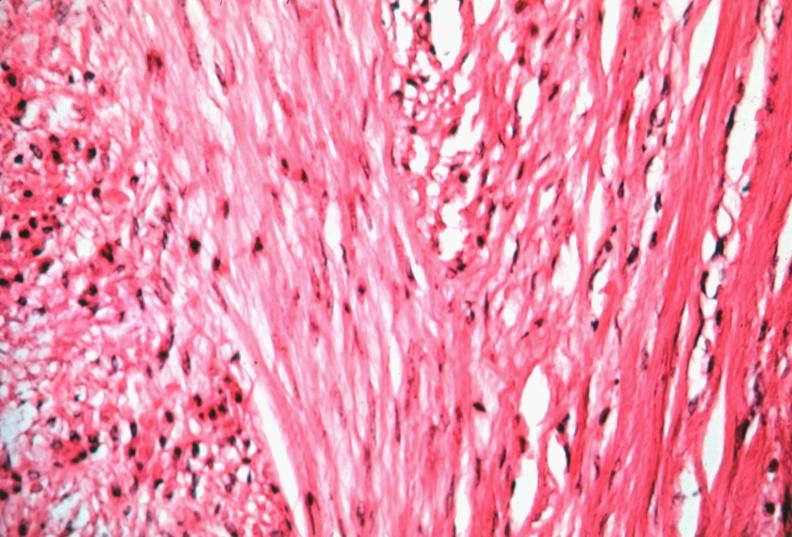what does this image show?
Answer the question using a single word or phrase. Uterus 